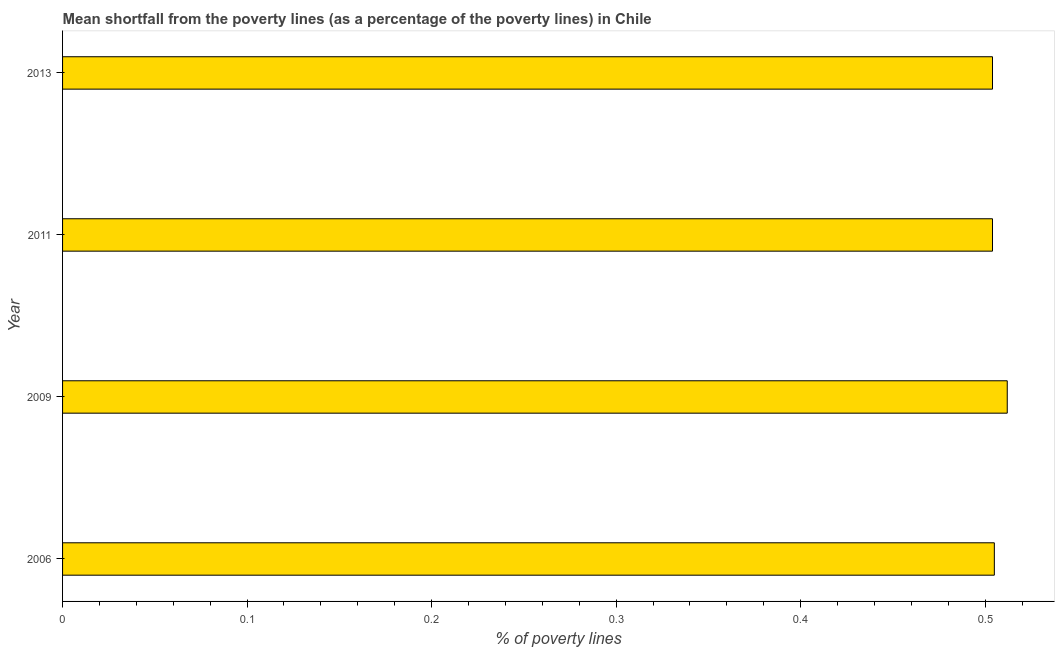Does the graph contain any zero values?
Offer a terse response. No. What is the title of the graph?
Offer a terse response. Mean shortfall from the poverty lines (as a percentage of the poverty lines) in Chile. What is the label or title of the X-axis?
Ensure brevity in your answer.  % of poverty lines. What is the label or title of the Y-axis?
Keep it short and to the point. Year. What is the poverty gap at national poverty lines in 2006?
Provide a short and direct response. 0.51. Across all years, what is the maximum poverty gap at national poverty lines?
Offer a terse response. 0.51. Across all years, what is the minimum poverty gap at national poverty lines?
Provide a short and direct response. 0.5. What is the sum of the poverty gap at national poverty lines?
Provide a succinct answer. 2.02. What is the difference between the poverty gap at national poverty lines in 2009 and 2011?
Offer a very short reply. 0.01. What is the average poverty gap at national poverty lines per year?
Provide a short and direct response. 0.51. What is the median poverty gap at national poverty lines?
Your answer should be very brief. 0.5. In how many years, is the poverty gap at national poverty lines greater than 0.28 %?
Ensure brevity in your answer.  4. Do a majority of the years between 2009 and 2006 (inclusive) have poverty gap at national poverty lines greater than 0.4 %?
Provide a short and direct response. No. Is the poverty gap at national poverty lines in 2006 less than that in 2009?
Ensure brevity in your answer.  Yes. Is the difference between the poverty gap at national poverty lines in 2009 and 2013 greater than the difference between any two years?
Provide a short and direct response. Yes. What is the difference between the highest and the second highest poverty gap at national poverty lines?
Your answer should be compact. 0.01. In how many years, is the poverty gap at national poverty lines greater than the average poverty gap at national poverty lines taken over all years?
Give a very brief answer. 1. Are all the bars in the graph horizontal?
Offer a very short reply. Yes. What is the % of poverty lines of 2006?
Provide a short and direct response. 0.51. What is the % of poverty lines of 2009?
Offer a very short reply. 0.51. What is the % of poverty lines in 2011?
Your response must be concise. 0.5. What is the % of poverty lines of 2013?
Your answer should be very brief. 0.5. What is the difference between the % of poverty lines in 2006 and 2009?
Keep it short and to the point. -0.01. What is the difference between the % of poverty lines in 2009 and 2011?
Make the answer very short. 0.01. What is the difference between the % of poverty lines in 2009 and 2013?
Your answer should be compact. 0.01. What is the difference between the % of poverty lines in 2011 and 2013?
Make the answer very short. 0. What is the ratio of the % of poverty lines in 2006 to that in 2013?
Your response must be concise. 1. What is the ratio of the % of poverty lines in 2011 to that in 2013?
Provide a succinct answer. 1. 